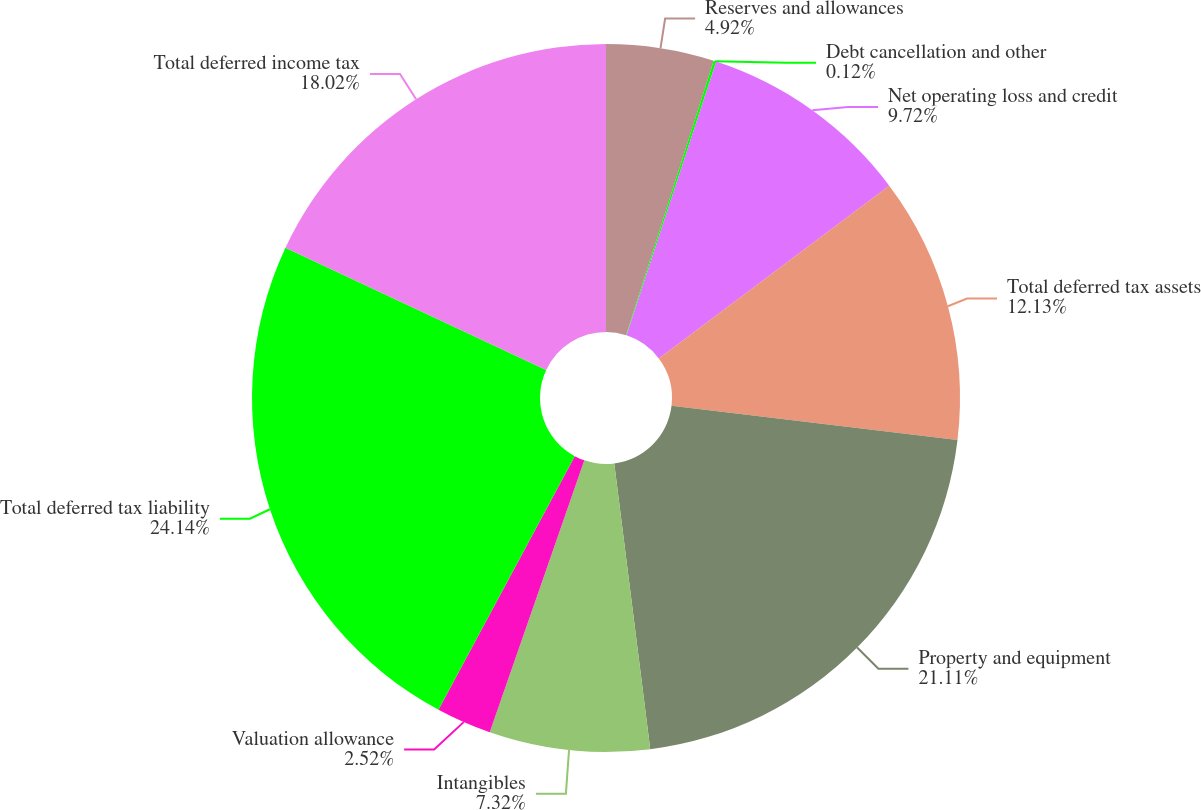Convert chart. <chart><loc_0><loc_0><loc_500><loc_500><pie_chart><fcel>Reserves and allowances<fcel>Debt cancellation and other<fcel>Net operating loss and credit<fcel>Total deferred tax assets<fcel>Property and equipment<fcel>Intangibles<fcel>Valuation allowance<fcel>Total deferred tax liability<fcel>Total deferred income tax<nl><fcel>4.92%<fcel>0.12%<fcel>9.72%<fcel>12.13%<fcel>21.11%<fcel>7.32%<fcel>2.52%<fcel>24.13%<fcel>18.02%<nl></chart> 